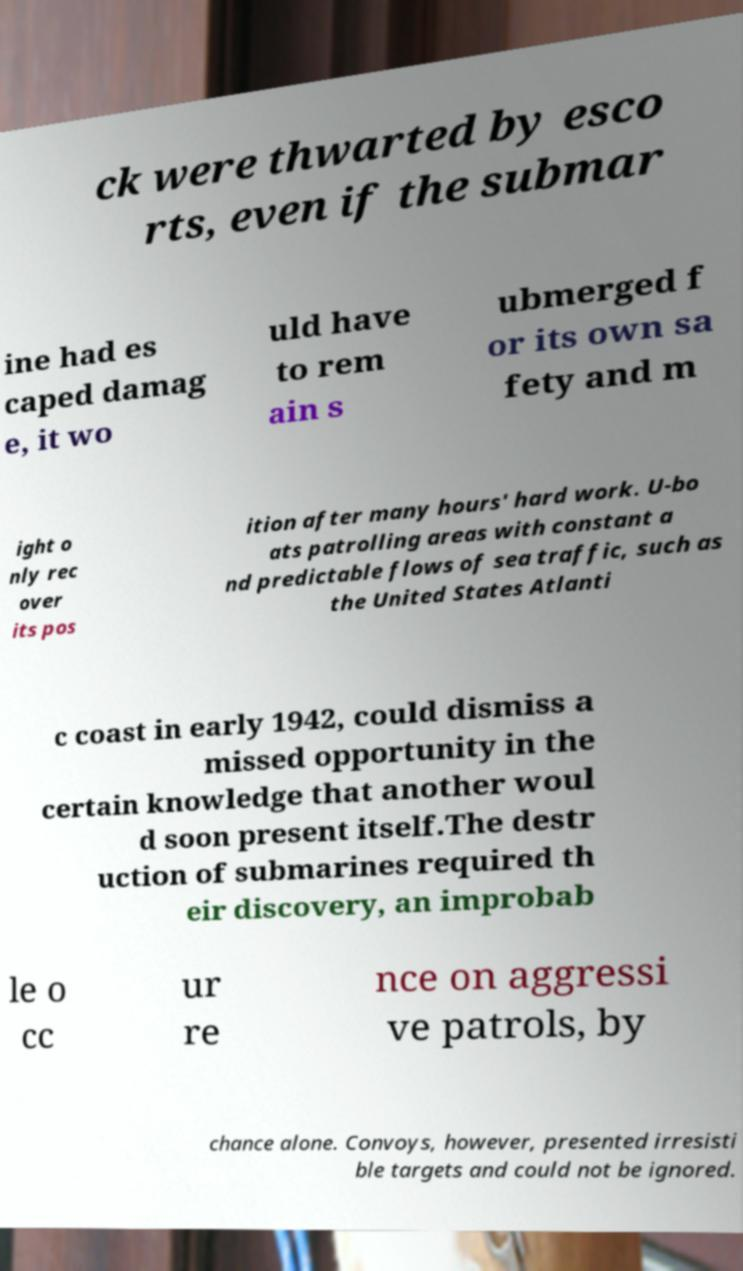Can you read and provide the text displayed in the image?This photo seems to have some interesting text. Can you extract and type it out for me? ck were thwarted by esco rts, even if the submar ine had es caped damag e, it wo uld have to rem ain s ubmerged f or its own sa fety and m ight o nly rec over its pos ition after many hours' hard work. U-bo ats patrolling areas with constant a nd predictable flows of sea traffic, such as the United States Atlanti c coast in early 1942, could dismiss a missed opportunity in the certain knowledge that another woul d soon present itself.The destr uction of submarines required th eir discovery, an improbab le o cc ur re nce on aggressi ve patrols, by chance alone. Convoys, however, presented irresisti ble targets and could not be ignored. 